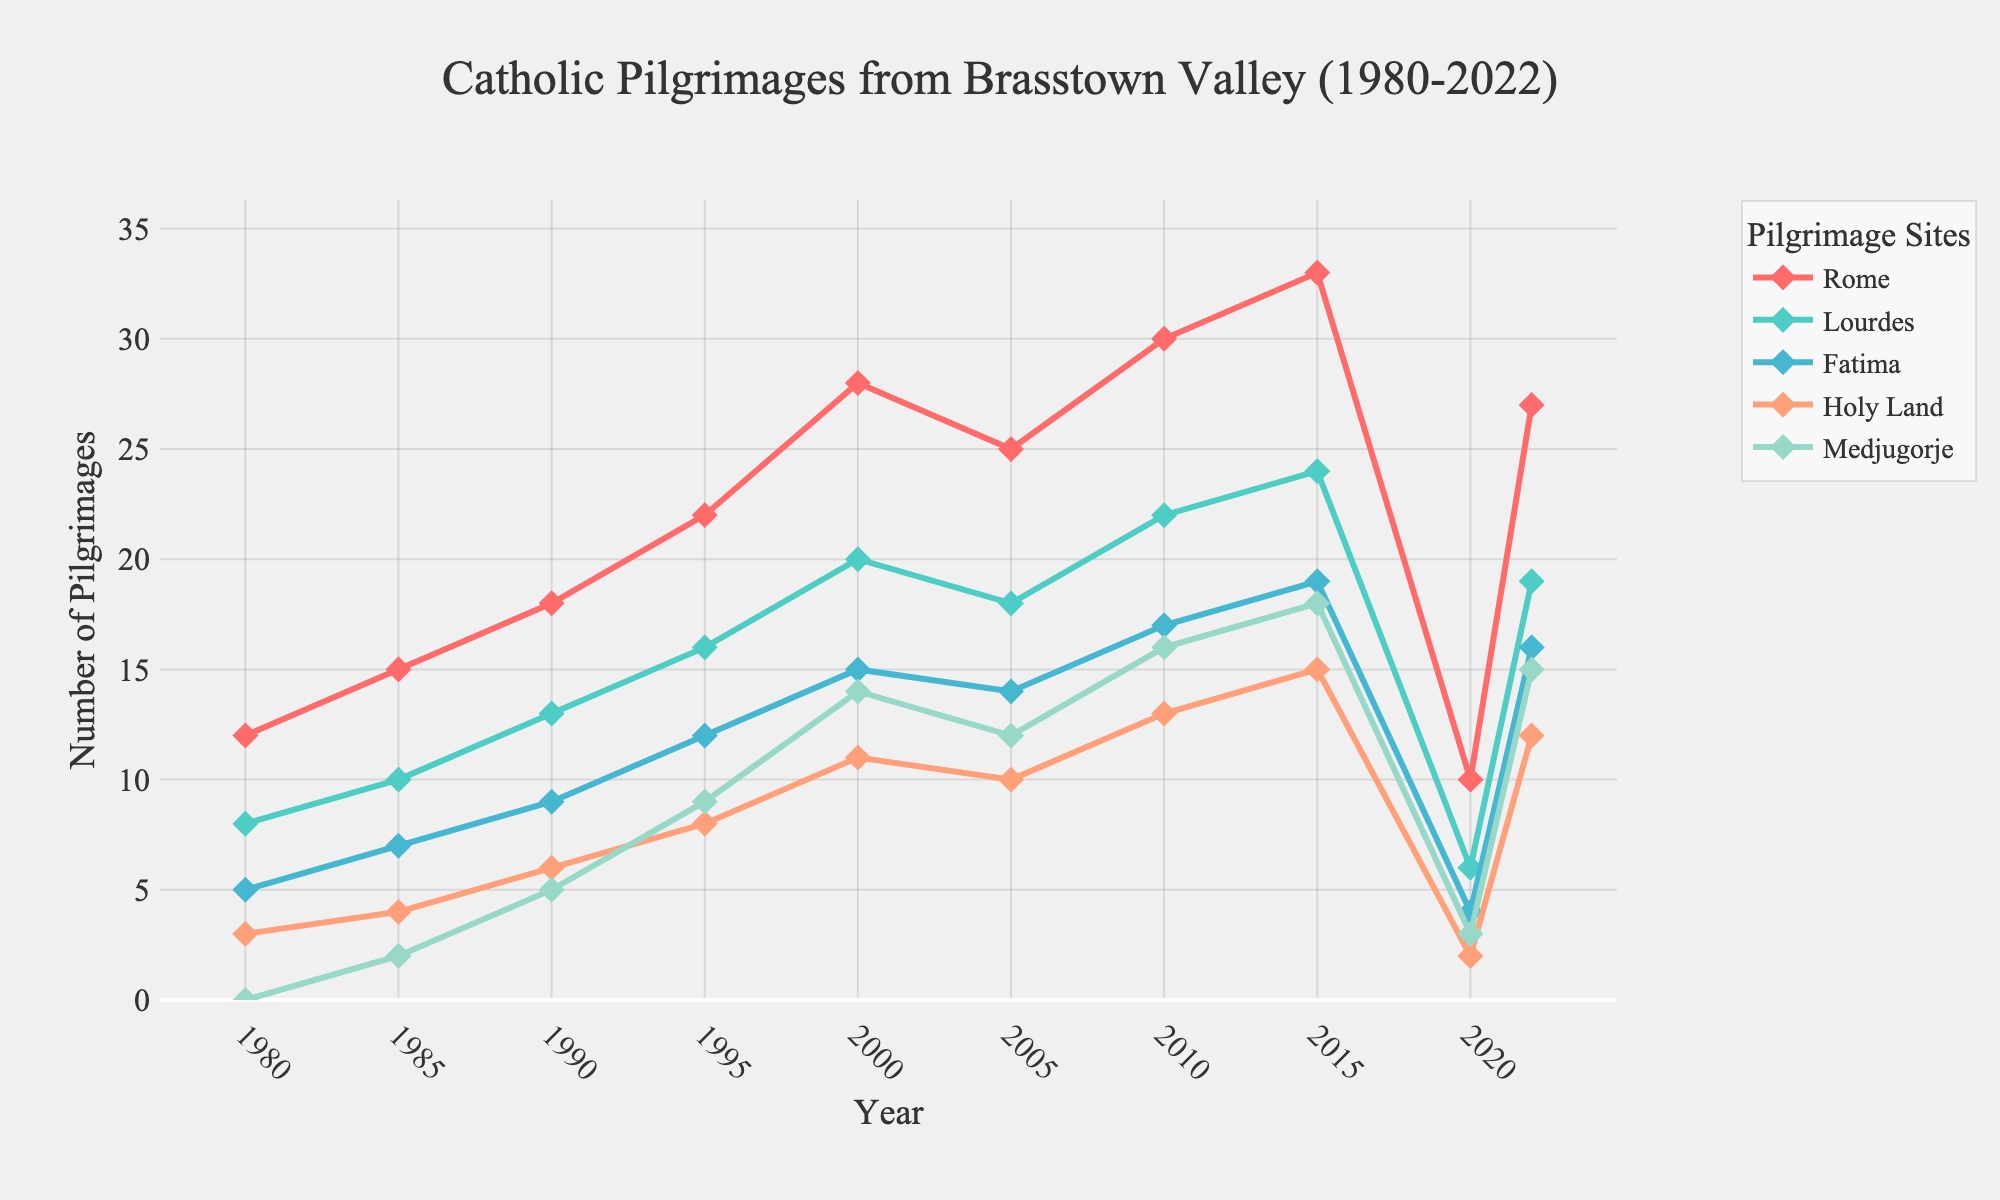What's the highest number of pilgrimages to Rome recorded on the chart? To find the highest number of pilgrimages to Rome, scan the line corresponding to Rome on the chart and identify the peak value. The highest point is at year 2015 with 33 pilgrimages.
Answer: 33 How did the number of pilgrimages to the Holy Land change from 2000 to 2020? Look at the value for the Holy Land in the years 2000 (11 pilgrimages) and 2020 (2 pilgrimages). Subtract the latter value from the former: 11 - 2 = 9. This indicates a decrease of 9 pilgrimages.
Answer: Decreased by 9 Which site experienced the sharpest drop in pilgrimages between 2015 and 2020? Compare the values for all sites between 2015 and 2020. Rome decreases from 33 to 10, Lourdes from 24 to 6, Fatima from 19 to 4, Holy Land from 15 to 2, Medjugorje from 18 to 3. Rome shows the sharpest drop with a decrease of 23 pilgrimages (33 - 10 = 23).
Answer: Rome In which year did Medjugorje first appear on the chart? Observe the years and values plotted for Medjugorje. The first non-zero value appears in 1985 with 2 pilgrimages.
Answer: 1985 Which pilgrimage site had the most consistent year-over-year increase until 2010? By visually inspecting the lines, Medjugorje shows the most consistent increase from its appearance in 1985 up to 2010 where it starts with 2, increasing almost steadily year-over-year up to 16 in 2010.
Answer: Medjugorje What is the average number of pilgrimages to Lourdes from 1980 to 2010? Sum up the pilgrimage numbers to Lourdes from 1980 (8), 1985 (10), 1990 (13), 1995 (16), 2000 (20), 2005 (18), and 2010 (22) and then divide by 7: (8 + 10 + 13 + 16 + 20 + 18 + 22) / 7 = 15.29.
Answer: 15.29 Which year shows the minimum number of total pilgrimages, combining all sites? Calculate the sum of pilgrimages for each year and compare. 2020: (10 + 6 + 4 + 2 + 3 = 25) is visibly the smallest compared to other years.
Answer: 2020 What was the difference in the number of pilgrimages to Fatima and Rome in 2022? In 2022, Fatima had 16 pilgrimages and Rome had 27 pilgrimages. The difference is 27 - 16 = 11.
Answer: 11 How does the number of pilgrimages in 2015 compare between Lourdes and Medjugorje? In 2015, Lourdes had 24 pilgrimages and Medjugorje had 18. Lourdes had more with a difference of 6 (24 - 18 = 6).
Answer: Lourdes had 6 more 